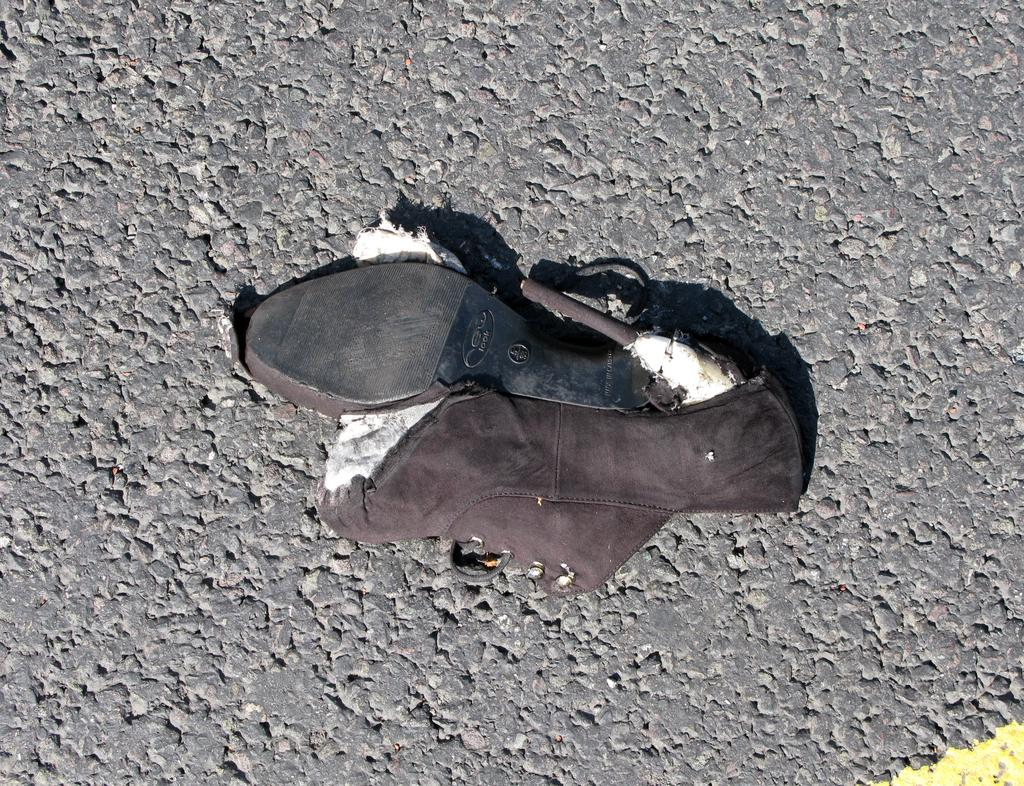What type of footwear is visible in the image? There is a sandal in the image. Can you describe the position or placement of the sandal in the image? The sandal is on a surface. What type of cream is being poured into the can in the image? There is no can or cream present in the image; it only features a sandal on a surface. 